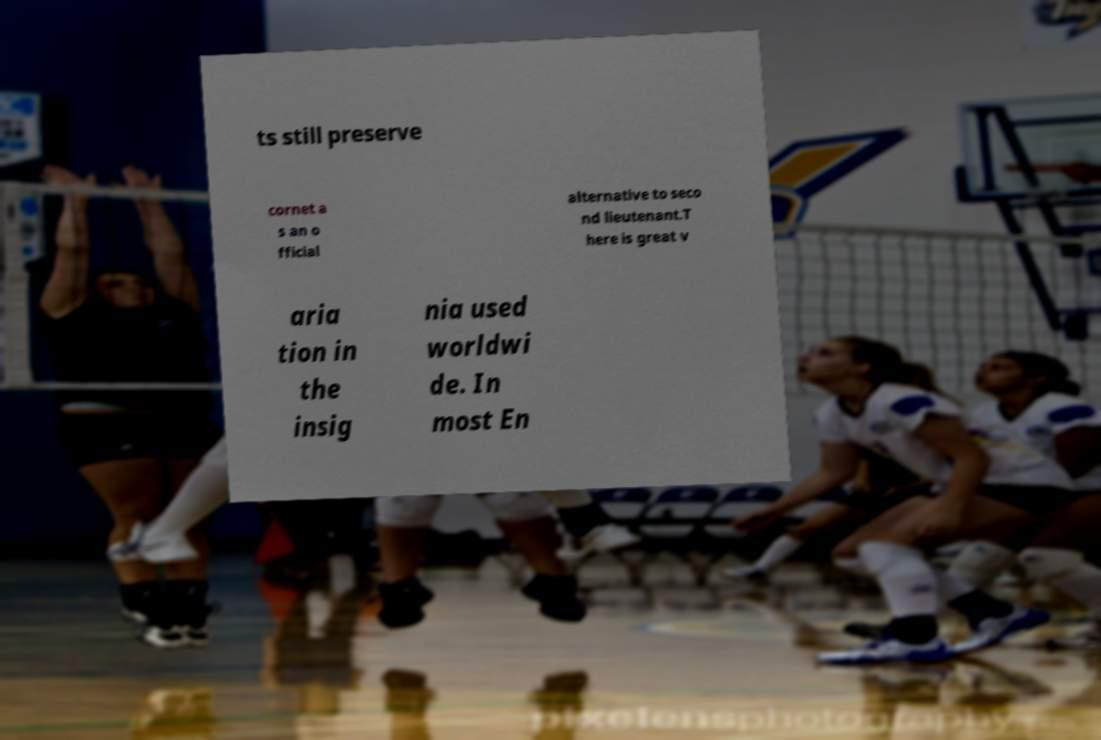Please read and relay the text visible in this image. What does it say? ts still preserve cornet a s an o fficial alternative to seco nd lieutenant.T here is great v aria tion in the insig nia used worldwi de. In most En 